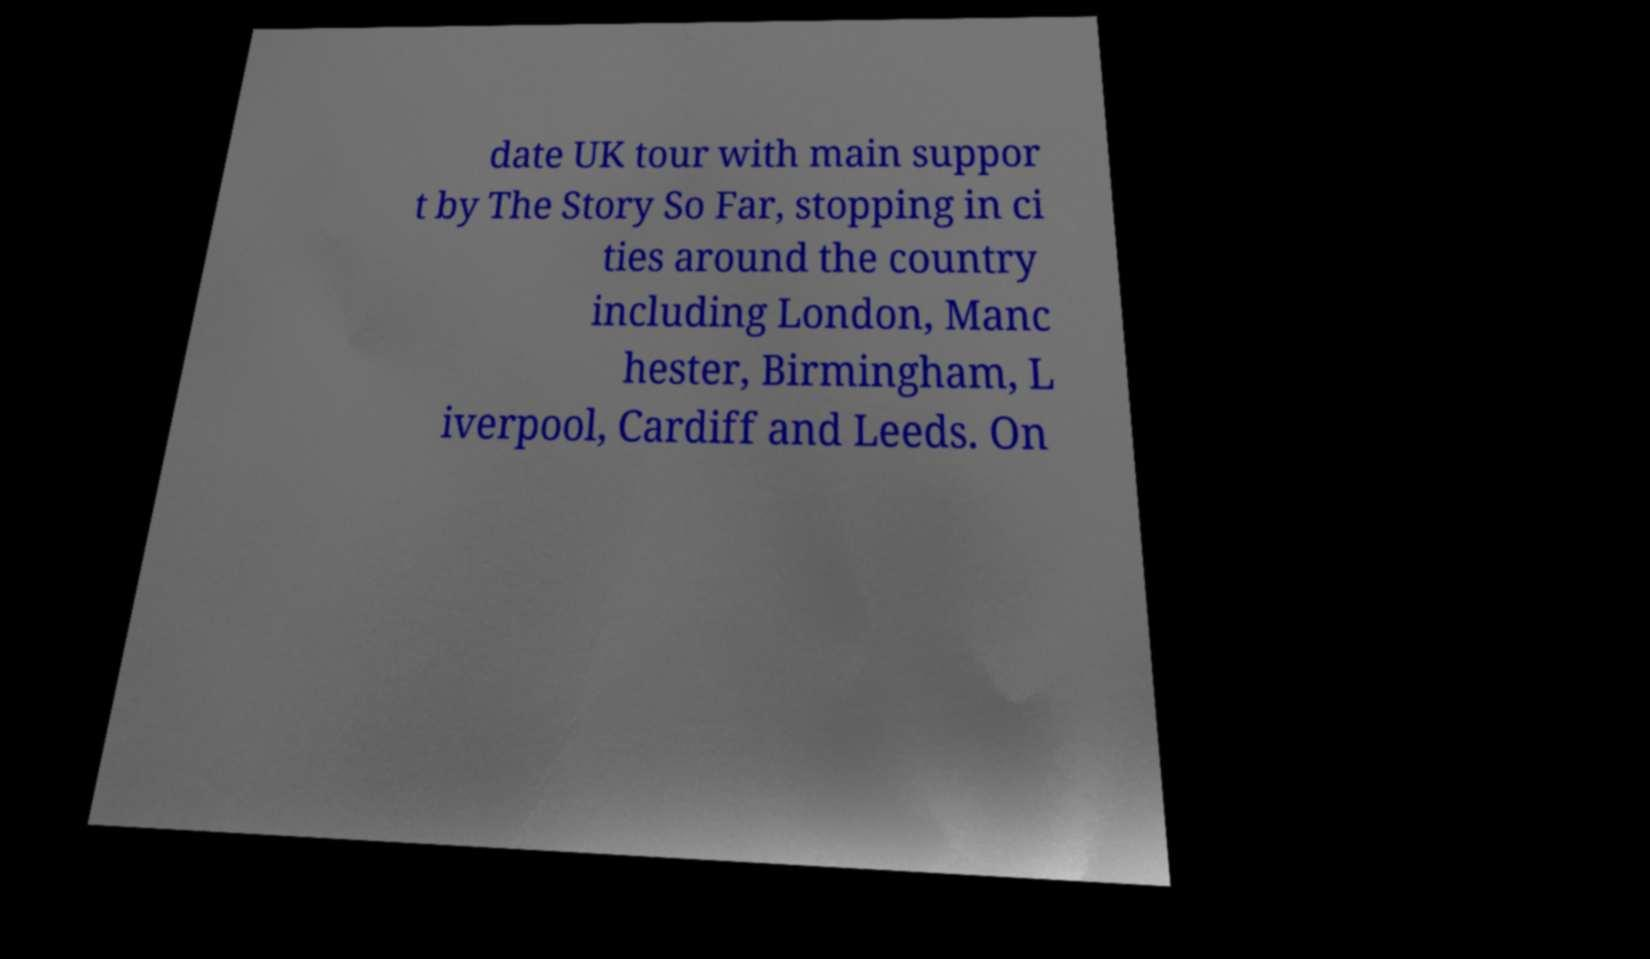Could you extract and type out the text from this image? date UK tour with main suppor t by The Story So Far, stopping in ci ties around the country including London, Manc hester, Birmingham, L iverpool, Cardiff and Leeds. On 